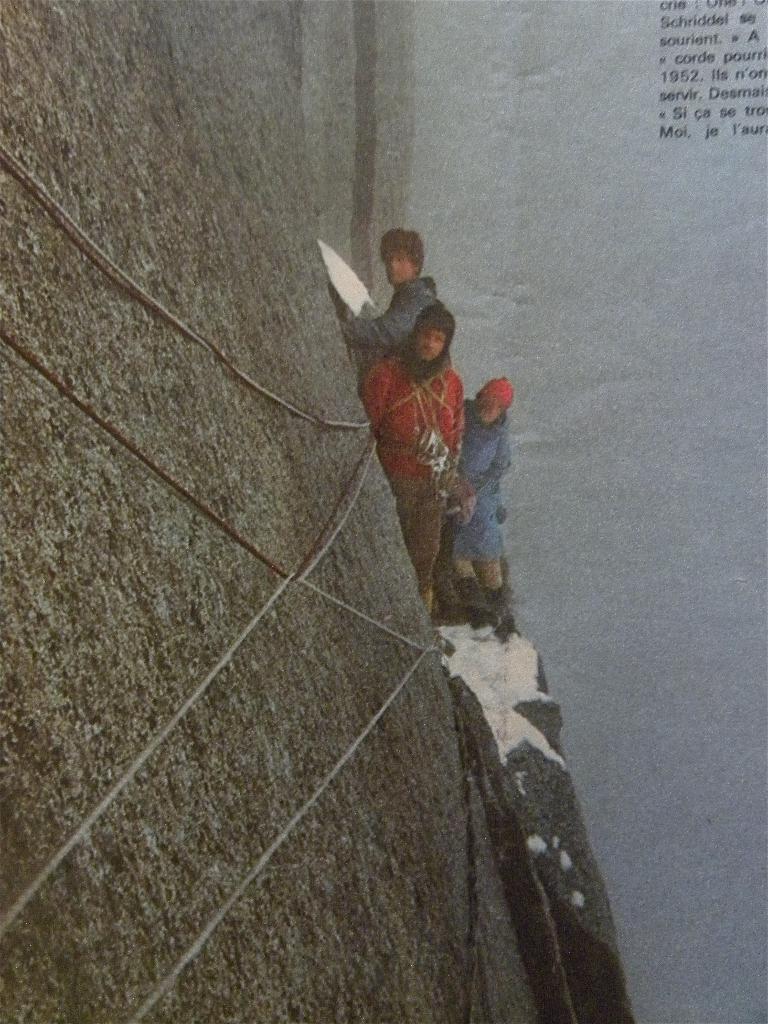Describe this image in one or two sentences. In this image I can see three people with different color dresses. I can see one person with the cap. To the left I can see the rope and rock. To the right I can see the text. 